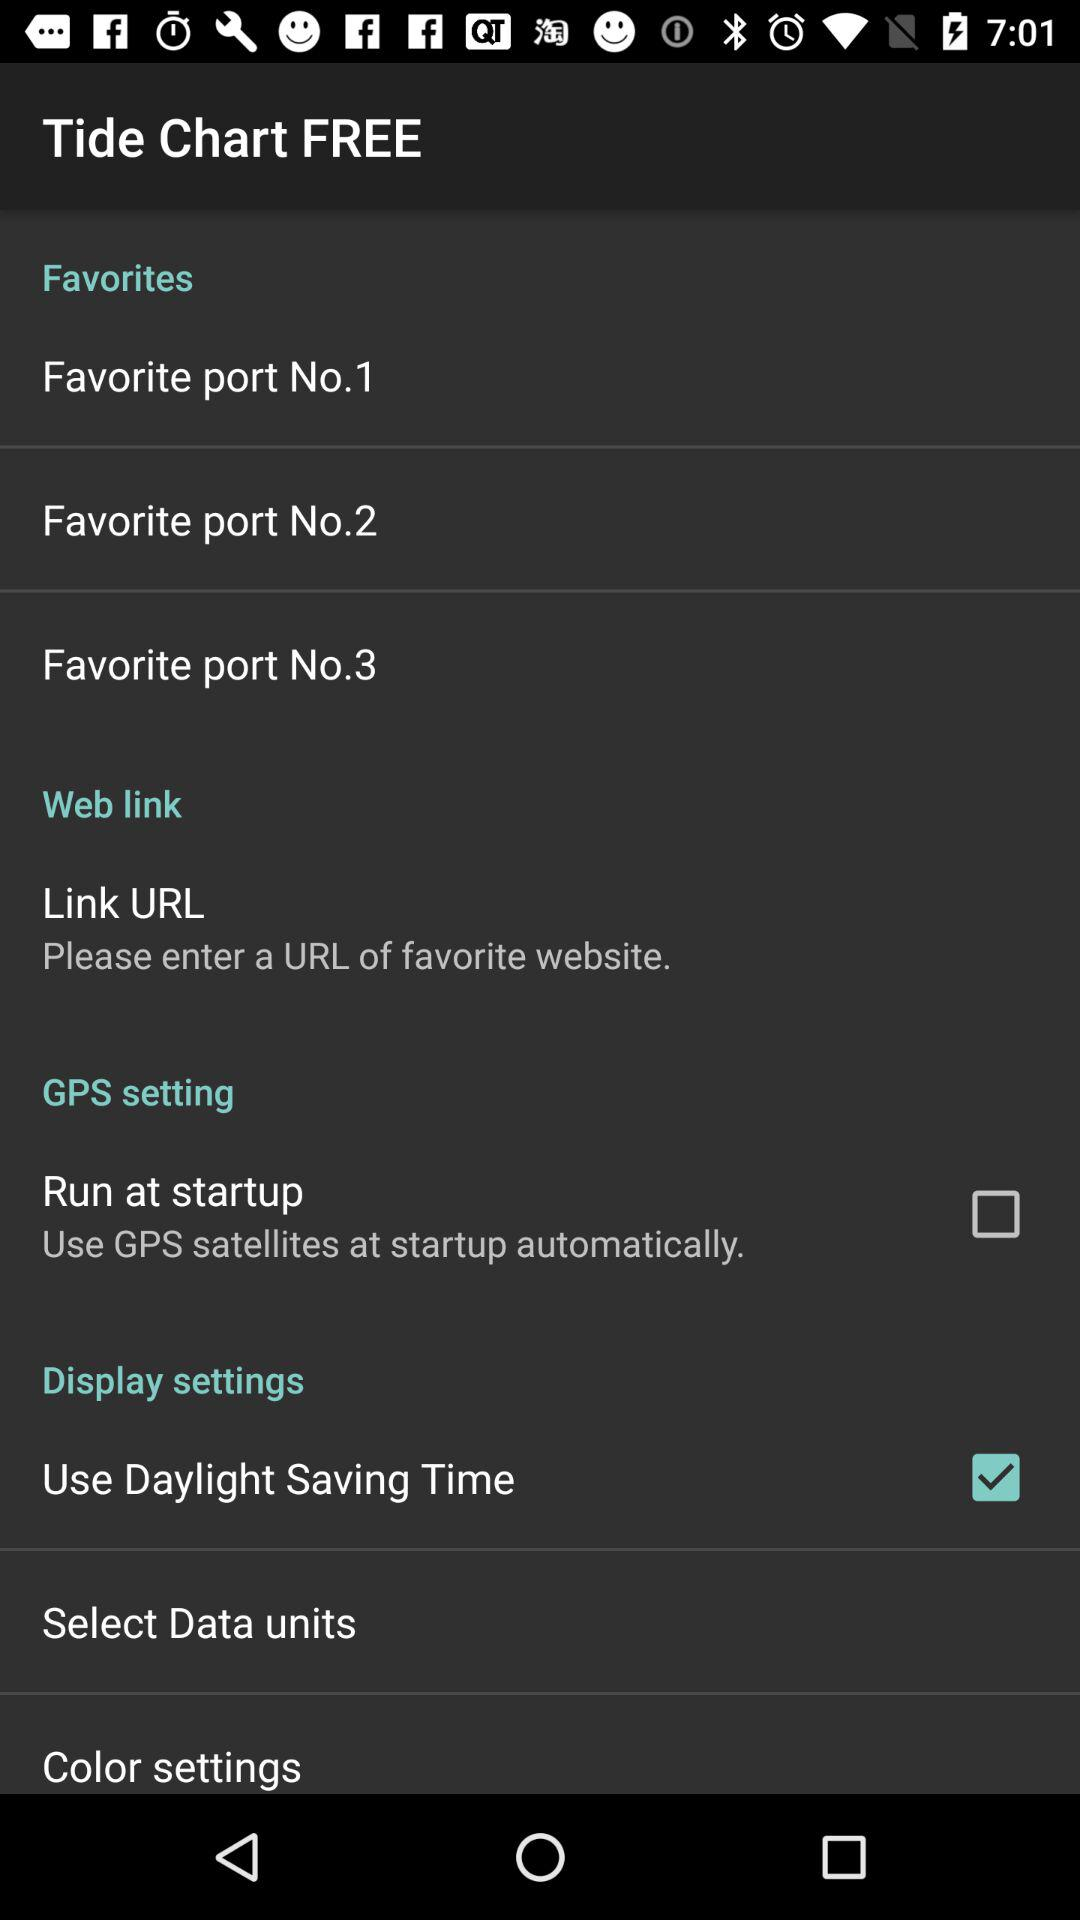What is the status of "Use Daylight Saving Time"? The status is "on". 